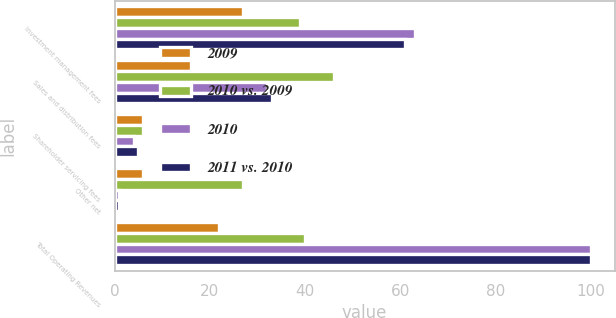<chart> <loc_0><loc_0><loc_500><loc_500><stacked_bar_chart><ecel><fcel>Investment management fees<fcel>Sales and distribution fees<fcel>Shareholder servicing fees<fcel>Other net<fcel>Total Operating Revenues<nl><fcel>2009<fcel>27<fcel>16<fcel>6<fcel>6<fcel>22<nl><fcel>2010 vs. 2009<fcel>39<fcel>46<fcel>6<fcel>27<fcel>40<nl><fcel>2010<fcel>63<fcel>32<fcel>4<fcel>1<fcel>100<nl><fcel>2011 vs. 2010<fcel>61<fcel>33<fcel>5<fcel>1<fcel>100<nl></chart> 